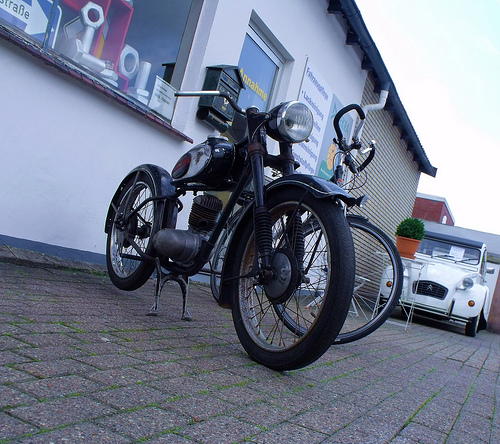<image>
Is there a car behind the motor cycle? No. The car is not behind the motor cycle. From this viewpoint, the car appears to be positioned elsewhere in the scene. 